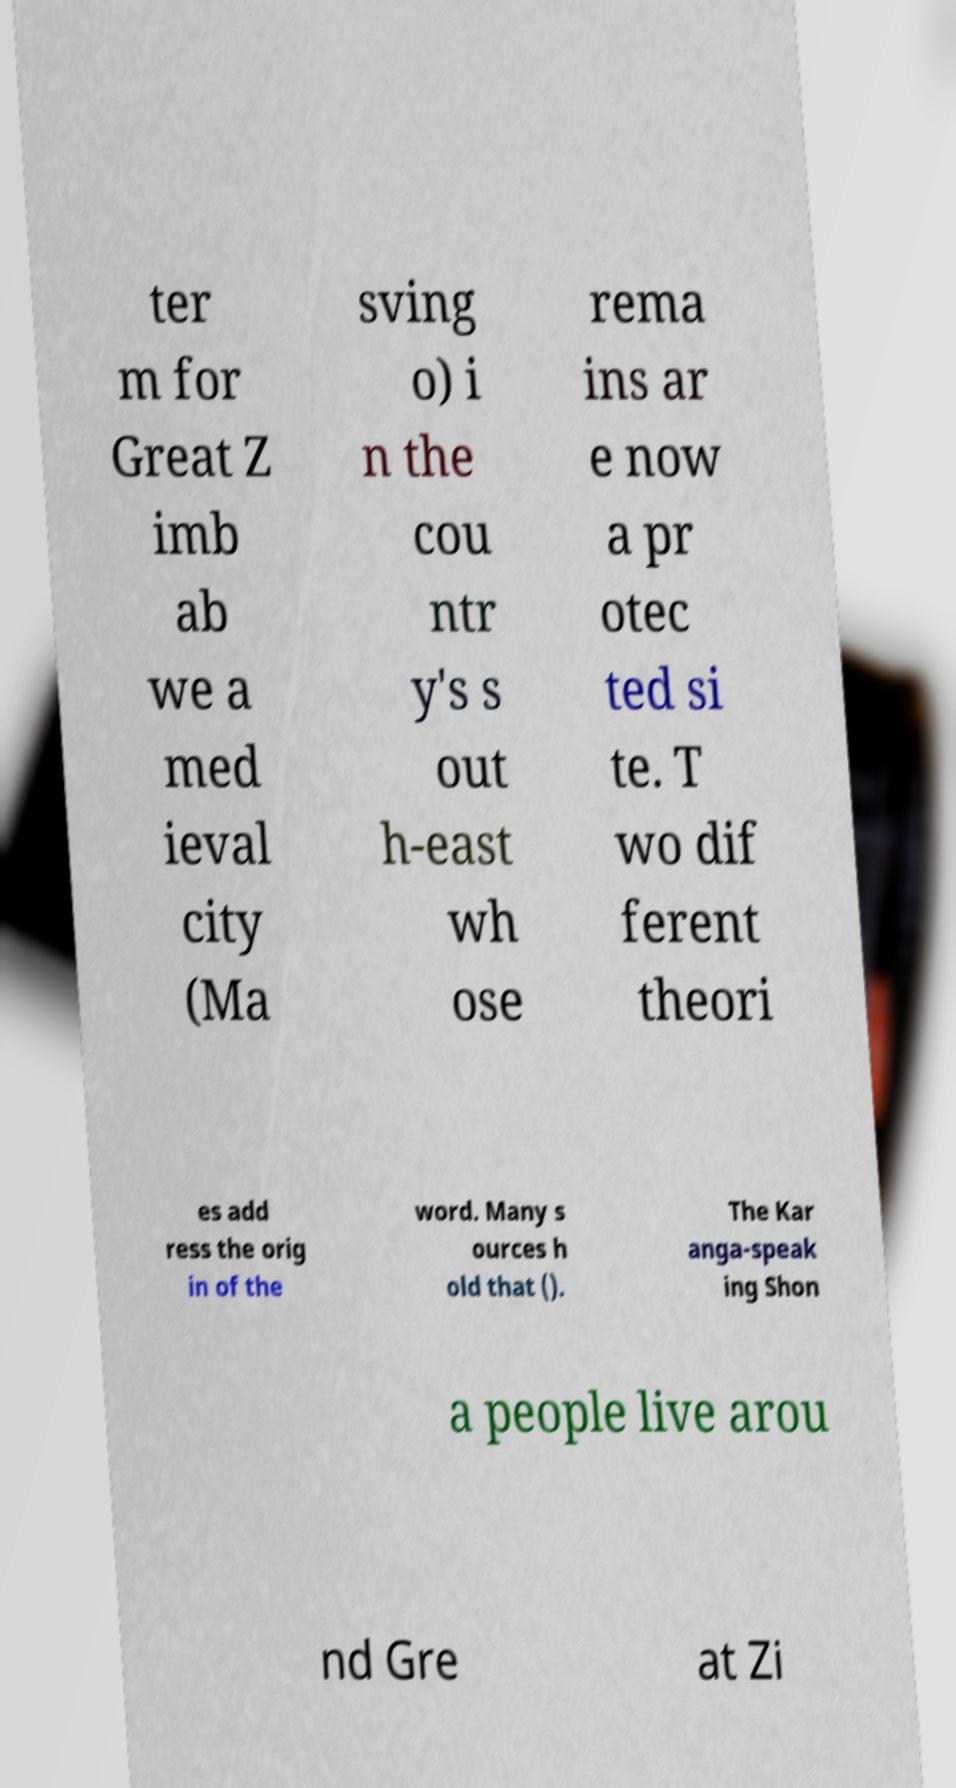For documentation purposes, I need the text within this image transcribed. Could you provide that? ter m for Great Z imb ab we a med ieval city (Ma sving o) i n the cou ntr y's s out h-east wh ose rema ins ar e now a pr otec ted si te. T wo dif ferent theori es add ress the orig in of the word. Many s ources h old that (). The Kar anga-speak ing Shon a people live arou nd Gre at Zi 